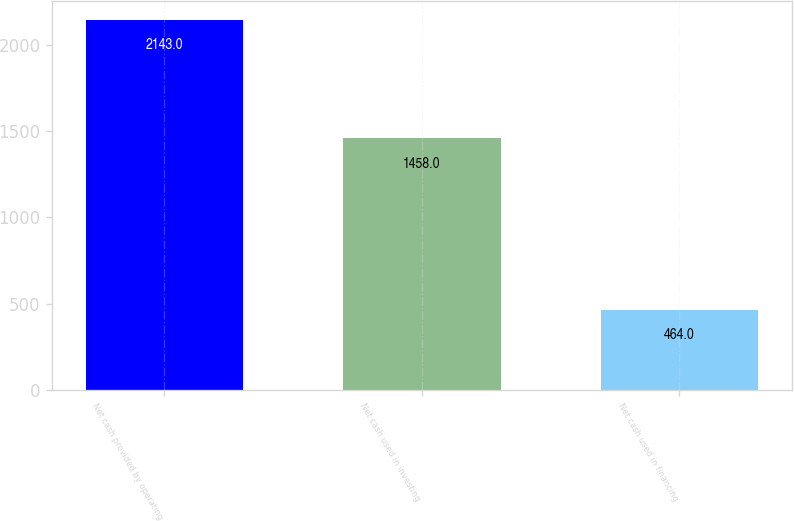<chart> <loc_0><loc_0><loc_500><loc_500><bar_chart><fcel>Net cash provided by operating<fcel>Net cash used in investing<fcel>Net cash used in financing<nl><fcel>2143<fcel>1458<fcel>464<nl></chart> 